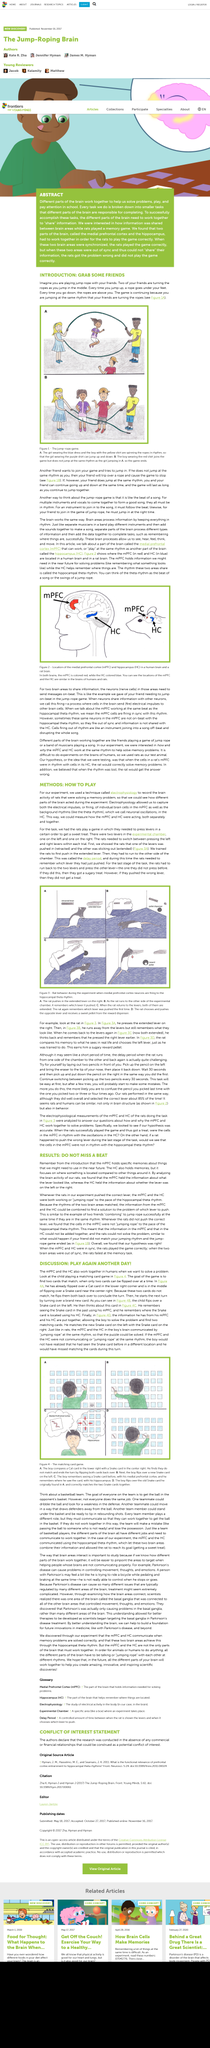Highlight a few significant elements in this photo. Electrophysiology has enabled the capture of electrical impulses. Rats are mentioned in the question. The information was held by HC. The title of this is 'Whats the title called? DO NOT MISS A BEAT..' The game ends when the boy does not jump at the same rhythm as Picture B. 